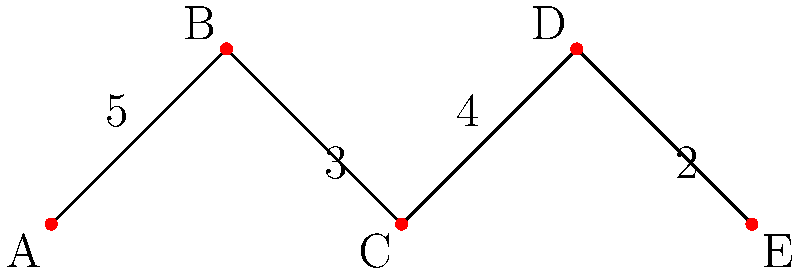You want to optimize the layout of your rubber tree plantation by connecting different sections with irrigation channels. The graph represents five sections (A, B, C, D, E) of your plantation, where the edges represent potential irrigation channels and the weights represent the cost (in millions) to construct each channel. What is the minimum cost to connect all sections of the plantation with irrigation channels? To find the minimum cost to connect all sections of the plantation, we need to find the Minimum Spanning Tree (MST) of the given graph. We can use Kruskal's algorithm to solve this problem:

1. Sort the edges by weight in ascending order:
   DE (2), BC (3), CD (4), AB (5)

2. Start with an empty set of edges and add edges in order, skipping those that would create a cycle:
   - Add DE (2)
   - Add BC (3)
   - Add CD (4)
   - Skip AB (5) as it would create a cycle

3. The resulting MST includes the edges:
   DE (2), BC (3), and CD (4)

4. Calculate the total cost:
   $2 + 3 + 4 = 9$ million

Therefore, the minimum cost to connect all sections of the plantation with irrigation channels is 9 million.
Answer: $9 million 